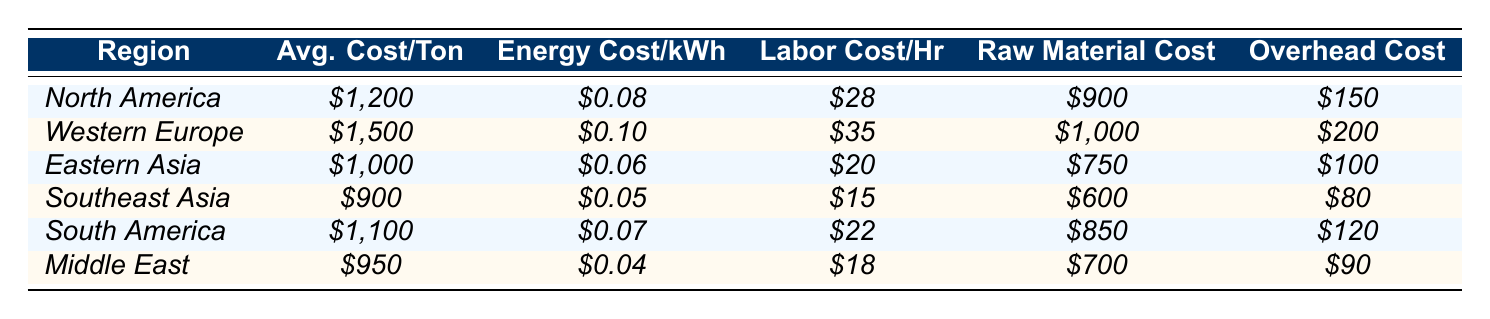What is the average cost per ton in Southeast Asia? The table shows that the average cost per ton in Southeast Asia is $900.
Answer: $900 Which region has the highest labor cost per hour? By inspecting the table, Western Europe shows the highest labor cost per hour at $35.
Answer: $35 How does the average cost per ton in North America compare to that in Eastern Asia? The average cost in North America is $1,200, while in Eastern Asia it is $1,000. The difference is $200, indicating North America is more expensive by that amount.
Answer: $200 more True or False: The energy cost per kWh is the lowest in Southeast Asia. The energy cost in Southeast Asia is $0.05, which is lower than all other regions listed in the table. Therefore, this statement is true.
Answer: True What is the total raw material cost for South America and Middle East combined? The raw material cost for South America is $850, and for the Middle East, it is $700. Adding these together gives $850 + $700 = $1,550.
Answer: $1,550 Which region has the lowest overhead cost, and what is that cost? The overhead cost is lowest in Southeast Asia at $80, as indicated in the table.
Answer: $80 If you were to calculate the average energy cost per kWh across all regions, what would it be? Collecting the energy costs: $0.08 + $0.10 + $0.06 + $0.05 + $0.07 + $0.04 = $0.40. There are 6 regions, so dividing gives $0.40 / 6 = $0.0667.
Answer: $0.0667 How much cheaper is the average cost per ton in Southeast Asia compared to Western Europe? Southeast Asia's average cost per ton is $900, while Western Europe's is $1,500. The difference is $1,500 - $900 = $600, indicating Southeast Asia is cheaper by that amount.
Answer: $600 cheaper If we consider labor and overhead costs, which region has the highest combined cost? Adding labor cost ($35) and overhead cost ($200) for Western Europe gives $35 + $200 = $235, which is the highest when comparing other regions.
Answer: $235 Is the raw material cost in Eastern Asia higher than in Southeast Asia? The raw material cost in Eastern Asia is $750, while in Southeast Asia it is $600. Therefore, Eastern Asia has a higher raw material cost.
Answer: Yes 